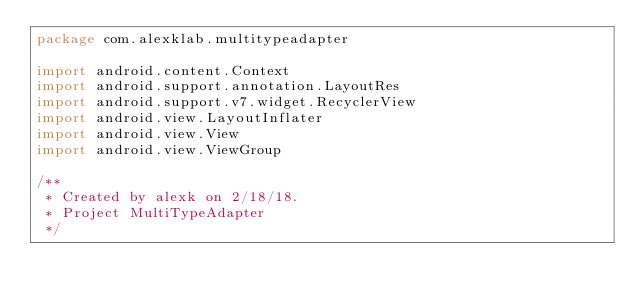<code> <loc_0><loc_0><loc_500><loc_500><_Kotlin_>package com.alexklab.multitypeadapter

import android.content.Context
import android.support.annotation.LayoutRes
import android.support.v7.widget.RecyclerView
import android.view.LayoutInflater
import android.view.View
import android.view.ViewGroup

/**
 * Created by alexk on 2/18/18.
 * Project MultiTypeAdapter
 */</code> 